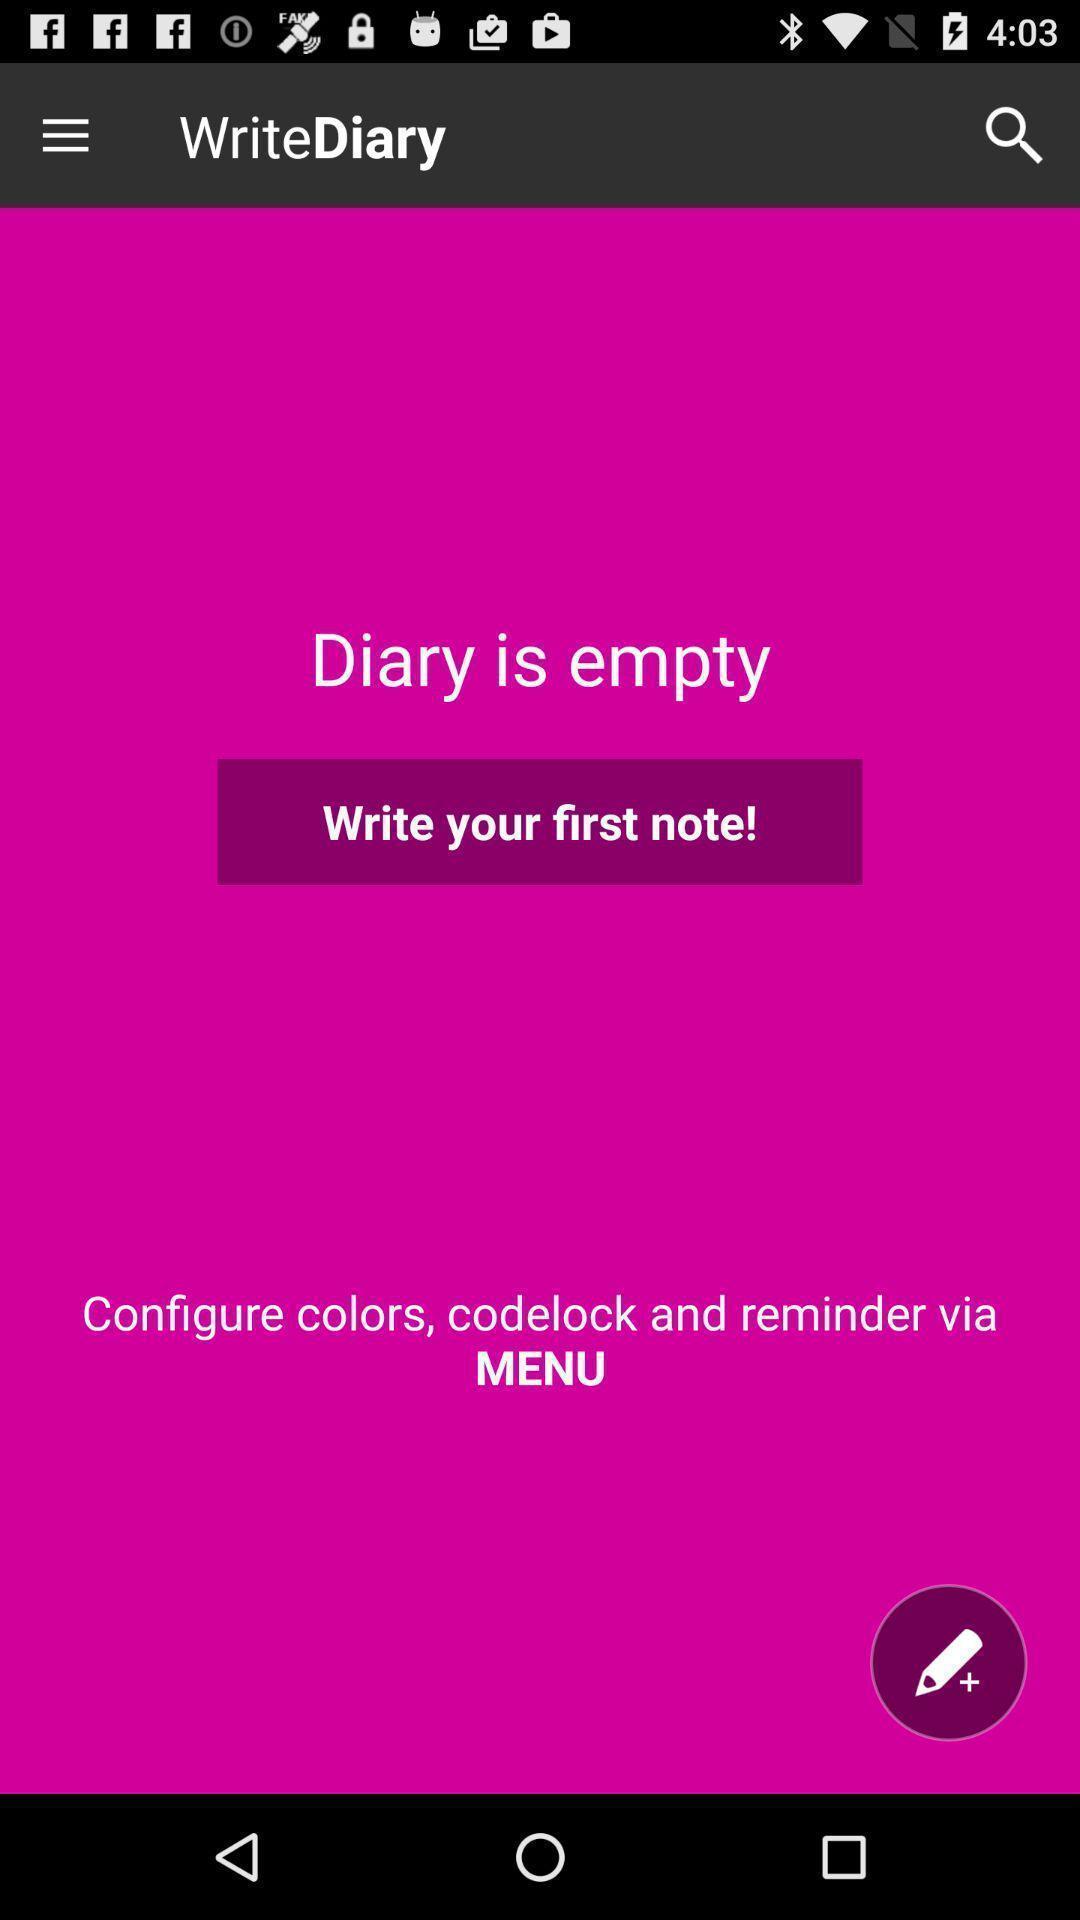Provide a detailed account of this screenshot. Welcome page of a diary app. 